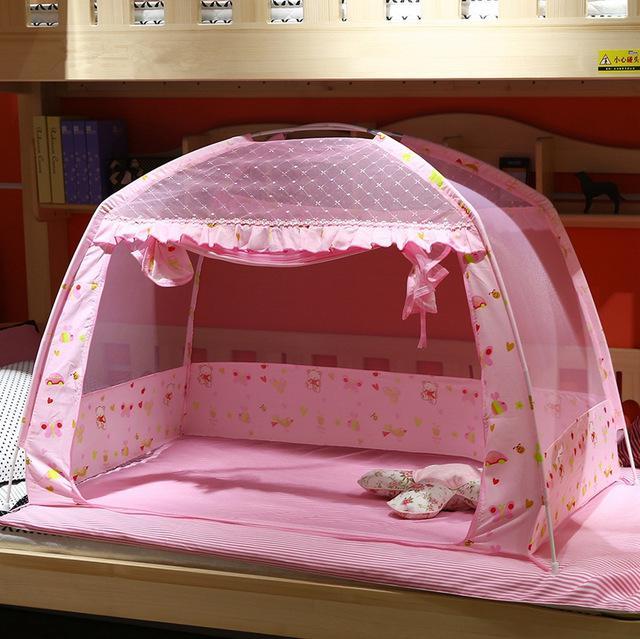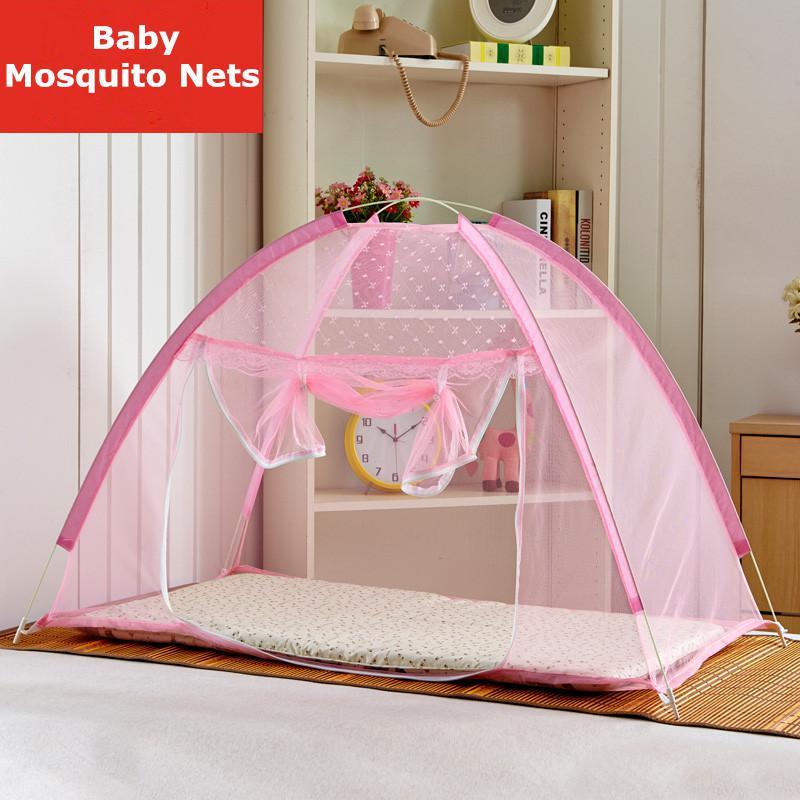The first image is the image on the left, the second image is the image on the right. Considering the images on both sides, is "There is exactly one baby crib." valid? Answer yes or no. No. The first image is the image on the left, the second image is the image on the right. Analyze the images presented: Is the assertion "There are two pink canopies ." valid? Answer yes or no. Yes. 